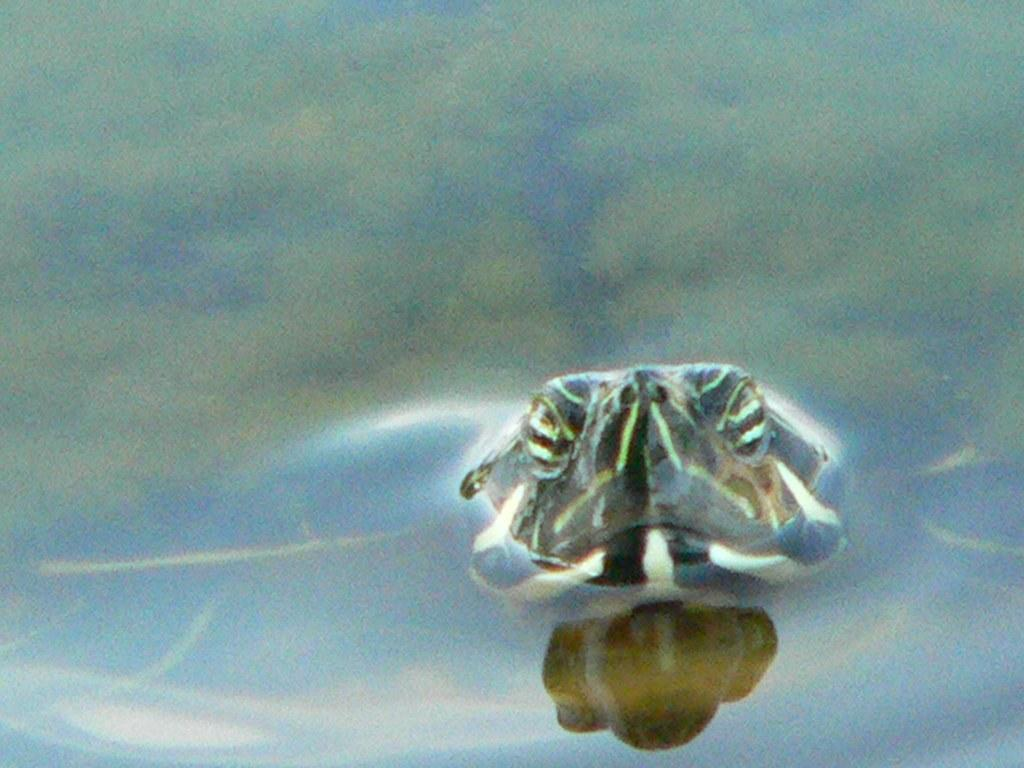What type of animal can be seen in the image? There is a mammal in the water in the image. What type of spy equipment can be seen in the image? There is no spy equipment present in the image; it features a mammal in the water. What type of vase is visible in the image? There is no vase present in the image; it features a mammal in the water. 